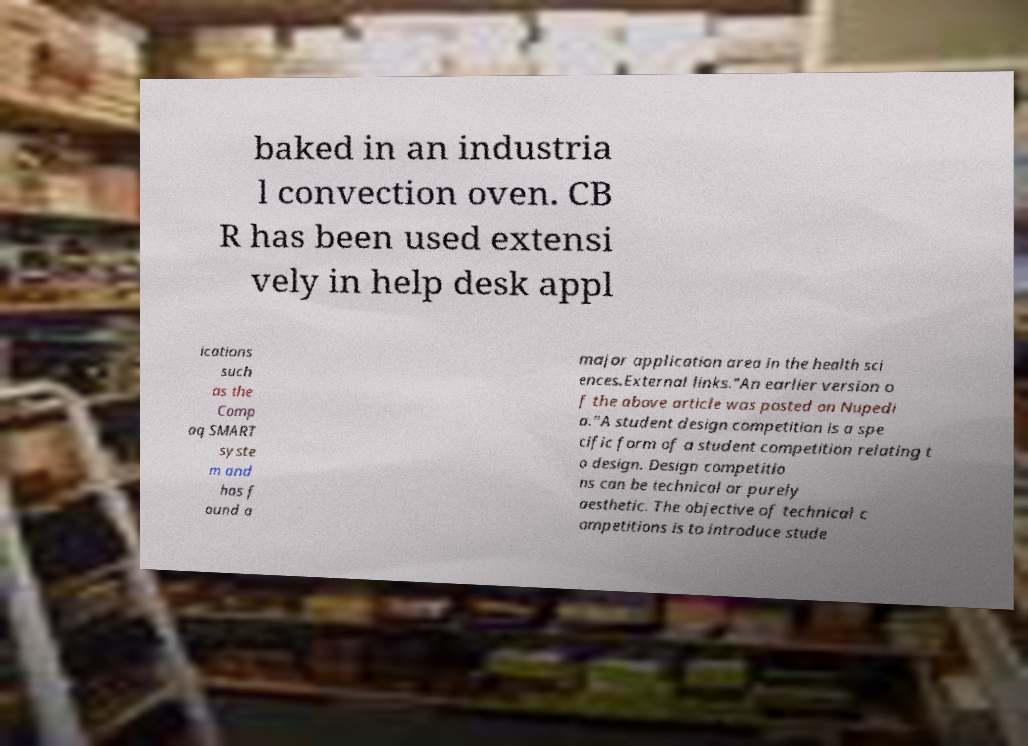What messages or text are displayed in this image? I need them in a readable, typed format. baked in an industria l convection oven. CB R has been used extensi vely in help desk appl ications such as the Comp aq SMART syste m and has f ound a major application area in the health sci ences.External links."An earlier version o f the above article was posted on Nupedi a."A student design competition is a spe cific form of a student competition relating t o design. Design competitio ns can be technical or purely aesthetic. The objective of technical c ompetitions is to introduce stude 